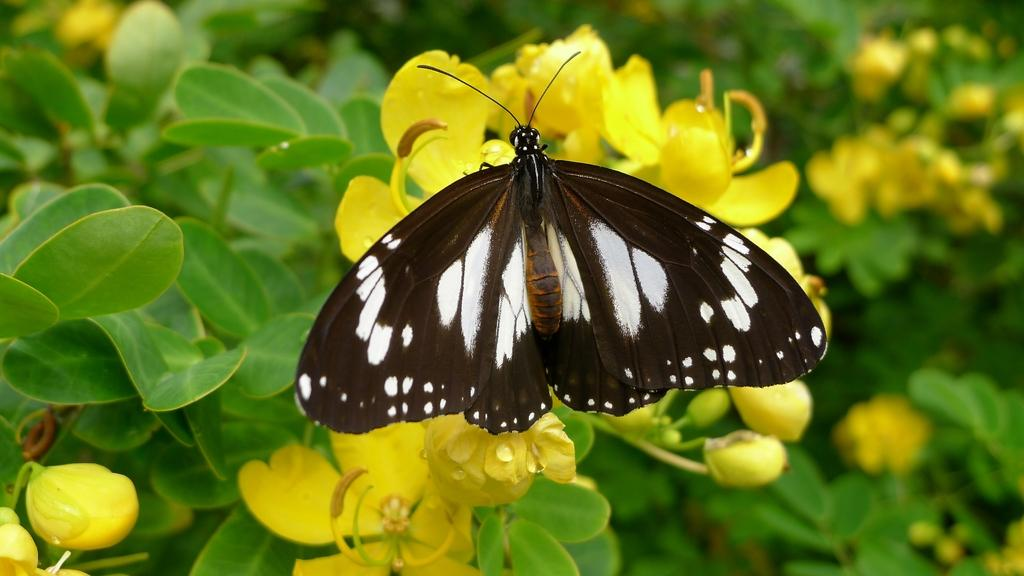What is the main subject of the image? There is a butterfly in the image. Where is the butterfly located? The butterfly is on a flower. What color are the flowers in the image? The flowers are yellow. What are the flowers attached to? The flowers are on plants. What colors can be seen on the butterfly? The butterfly has black and white coloration. What time of day does the butterfly attack people in the image? The image does not depict the butterfly attacking people, and there is no indication of the time of day. 